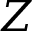<formula> <loc_0><loc_0><loc_500><loc_500>Z</formula> 